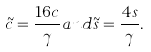Convert formula to latex. <formula><loc_0><loc_0><loc_500><loc_500>\tilde { c } = \frac { 1 6 c } { \gamma } a n d \tilde { s } = \frac { 4 s } { \gamma } .</formula> 